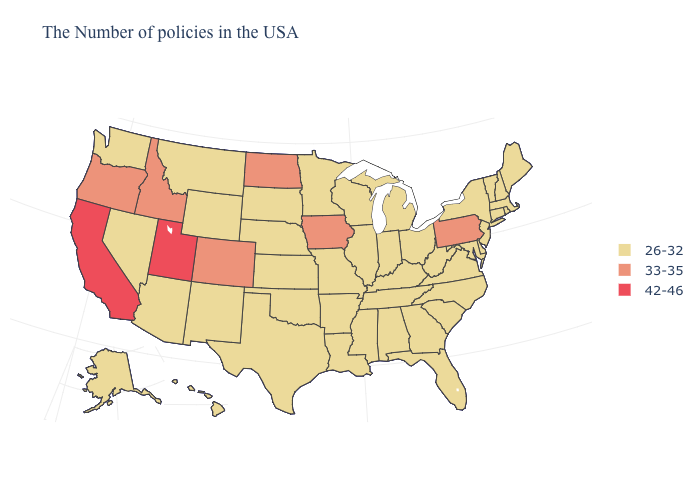Name the states that have a value in the range 42-46?
Keep it brief. Utah, California. What is the value of Maryland?
Write a very short answer. 26-32. Name the states that have a value in the range 33-35?
Concise answer only. Pennsylvania, Iowa, North Dakota, Colorado, Idaho, Oregon. Does California have the highest value in the USA?
Give a very brief answer. Yes. What is the lowest value in the USA?
Short answer required. 26-32. What is the value of North Dakota?
Short answer required. 33-35. What is the value of Nebraska?
Write a very short answer. 26-32. Name the states that have a value in the range 33-35?
Be succinct. Pennsylvania, Iowa, North Dakota, Colorado, Idaho, Oregon. What is the value of Maine?
Be succinct. 26-32. What is the value of Michigan?
Be succinct. 26-32. Among the states that border Maine , which have the lowest value?
Concise answer only. New Hampshire. Does Ohio have a lower value than Kansas?
Concise answer only. No. Name the states that have a value in the range 33-35?
Concise answer only. Pennsylvania, Iowa, North Dakota, Colorado, Idaho, Oregon. 